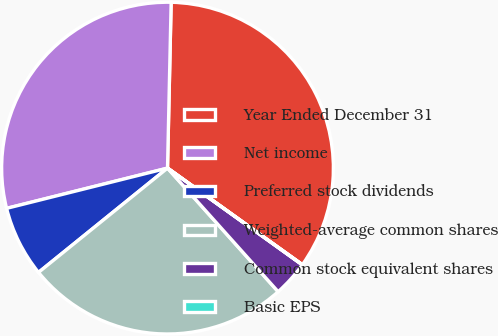Convert chart. <chart><loc_0><loc_0><loc_500><loc_500><pie_chart><fcel>Year Ended December 31<fcel>Net income<fcel>Preferred stock dividends<fcel>Weighted-average common shares<fcel>Common stock equivalent shares<fcel>Basic EPS<nl><fcel>34.54%<fcel>29.25%<fcel>6.92%<fcel>25.8%<fcel>3.47%<fcel>0.02%<nl></chart> 